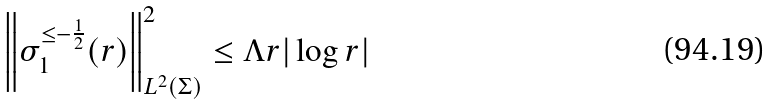<formula> <loc_0><loc_0><loc_500><loc_500>\left \| \sigma ^ { \leq - \frac { 1 } { 2 } } _ { 1 } ( r ) \right \| ^ { 2 } _ { L ^ { 2 } ( \Sigma ) } \leq \Lambda r | \log r |</formula> 